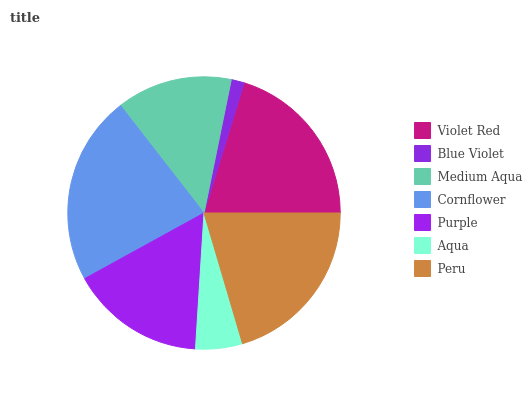Is Blue Violet the minimum?
Answer yes or no. Yes. Is Cornflower the maximum?
Answer yes or no. Yes. Is Medium Aqua the minimum?
Answer yes or no. No. Is Medium Aqua the maximum?
Answer yes or no. No. Is Medium Aqua greater than Blue Violet?
Answer yes or no. Yes. Is Blue Violet less than Medium Aqua?
Answer yes or no. Yes. Is Blue Violet greater than Medium Aqua?
Answer yes or no. No. Is Medium Aqua less than Blue Violet?
Answer yes or no. No. Is Purple the high median?
Answer yes or no. Yes. Is Purple the low median?
Answer yes or no. Yes. Is Violet Red the high median?
Answer yes or no. No. Is Medium Aqua the low median?
Answer yes or no. No. 